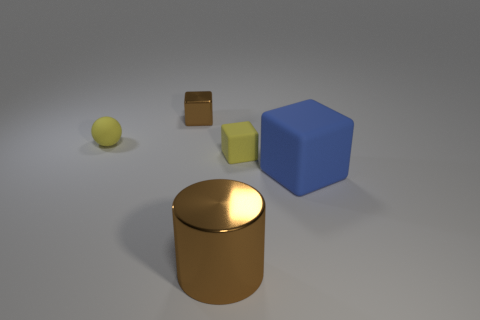Add 3 tiny yellow balls. How many objects exist? 8 Subtract all cylinders. How many objects are left? 4 Add 4 large cubes. How many large cubes exist? 5 Subtract 0 cyan cylinders. How many objects are left? 5 Subtract all big yellow metallic cubes. Subtract all small yellow rubber balls. How many objects are left? 4 Add 4 matte balls. How many matte balls are left? 5 